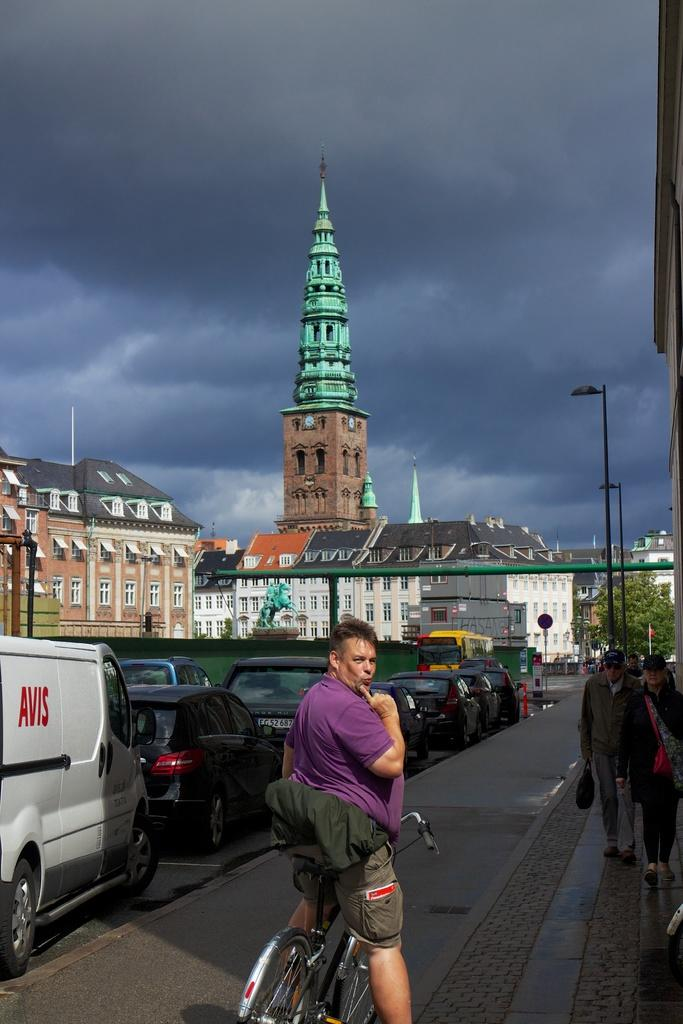What is the man in the image doing? The man is with his cycle in the image. Are there any other people in the image besides the man with the cycle? Yes, there are other people in the image. What can be seen in the background of the image? In the background of the image, there are cars, buildings, street lights, a tree, and a cloudy sky. What type of trade is being conducted in the image? There is no indication of any trade being conducted in the image. Can you describe the part of the plough that is visible in the image? There is no plough present in the image. 